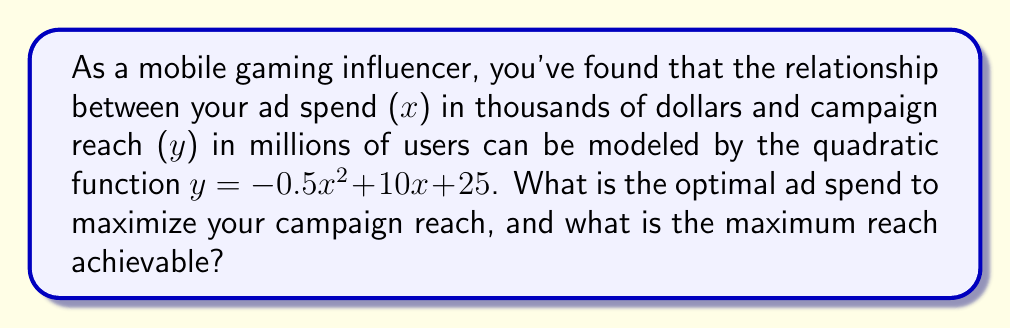Could you help me with this problem? To optimize the quadratic function and find the maximum reach, we need to follow these steps:

1) The quadratic function is in the form $y = ax^2 + bx + c$, where:
   $a = -0.5$, $b = 10$, and $c = 25$

2) For a quadratic function, the x-coordinate of the vertex represents the optimal input (in this case, the optimal ad spend). The formula for this is:
   $$x = -\frac{b}{2a}$$

3) Let's substitute our values:
   $$x = -\frac{10}{2(-0.5)} = -\frac{10}{-1} = 10$$

4) This means the optimal ad spend is $10,000 (since x is in thousands of dollars).

5) To find the maximum reach, we substitute this x-value back into our original function:
   $$y = -0.5(10)^2 + 10(10) + 25$$
   $$y = -0.5(100) + 100 + 25$$
   $$y = -50 + 100 + 25 = 75$$

6) Therefore, the maximum reach is 75 million users.
Answer: Optimal ad spend: $10,000; Maximum reach: 75 million users 